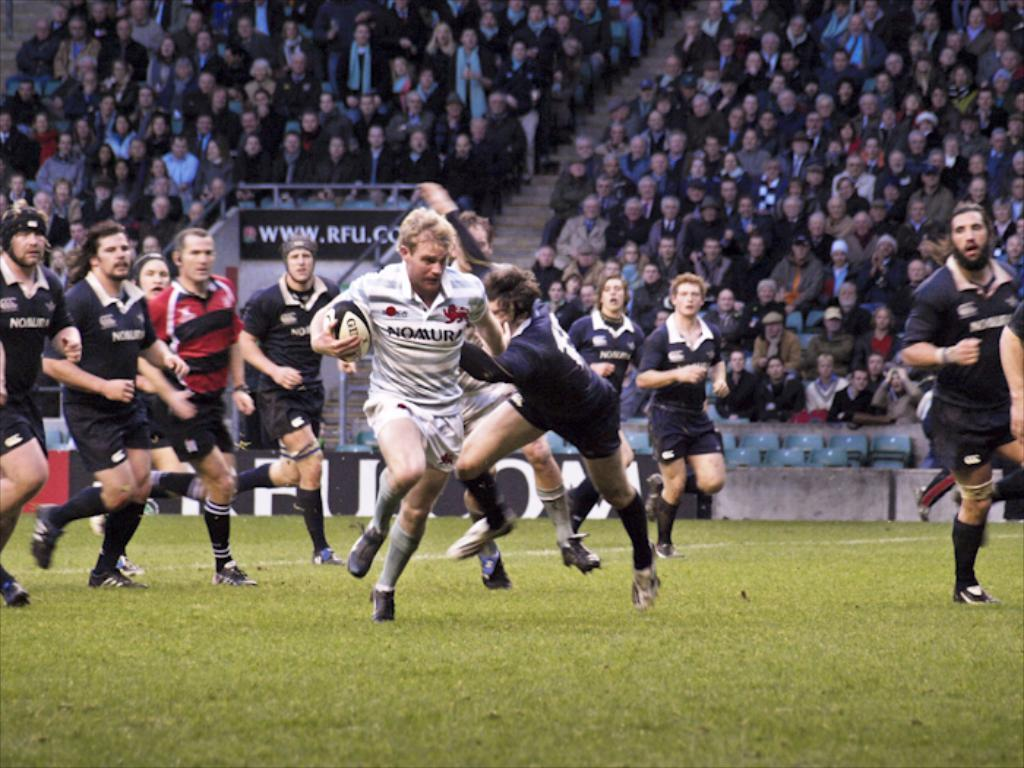What type of people can be seen in the image? There is a group of sports people in the image. Where are the sports people located? The sports people are on the floor. What are the sports people wearing? The sports people are wearing jerseys. Can you describe the people in the background of the image? There are people sitting on chairs in the background of the image. What type of mountain can be seen in the background of the image? There is no mountain present in the image; it features a group of sports people on the floor and people sitting on chairs in the background. 